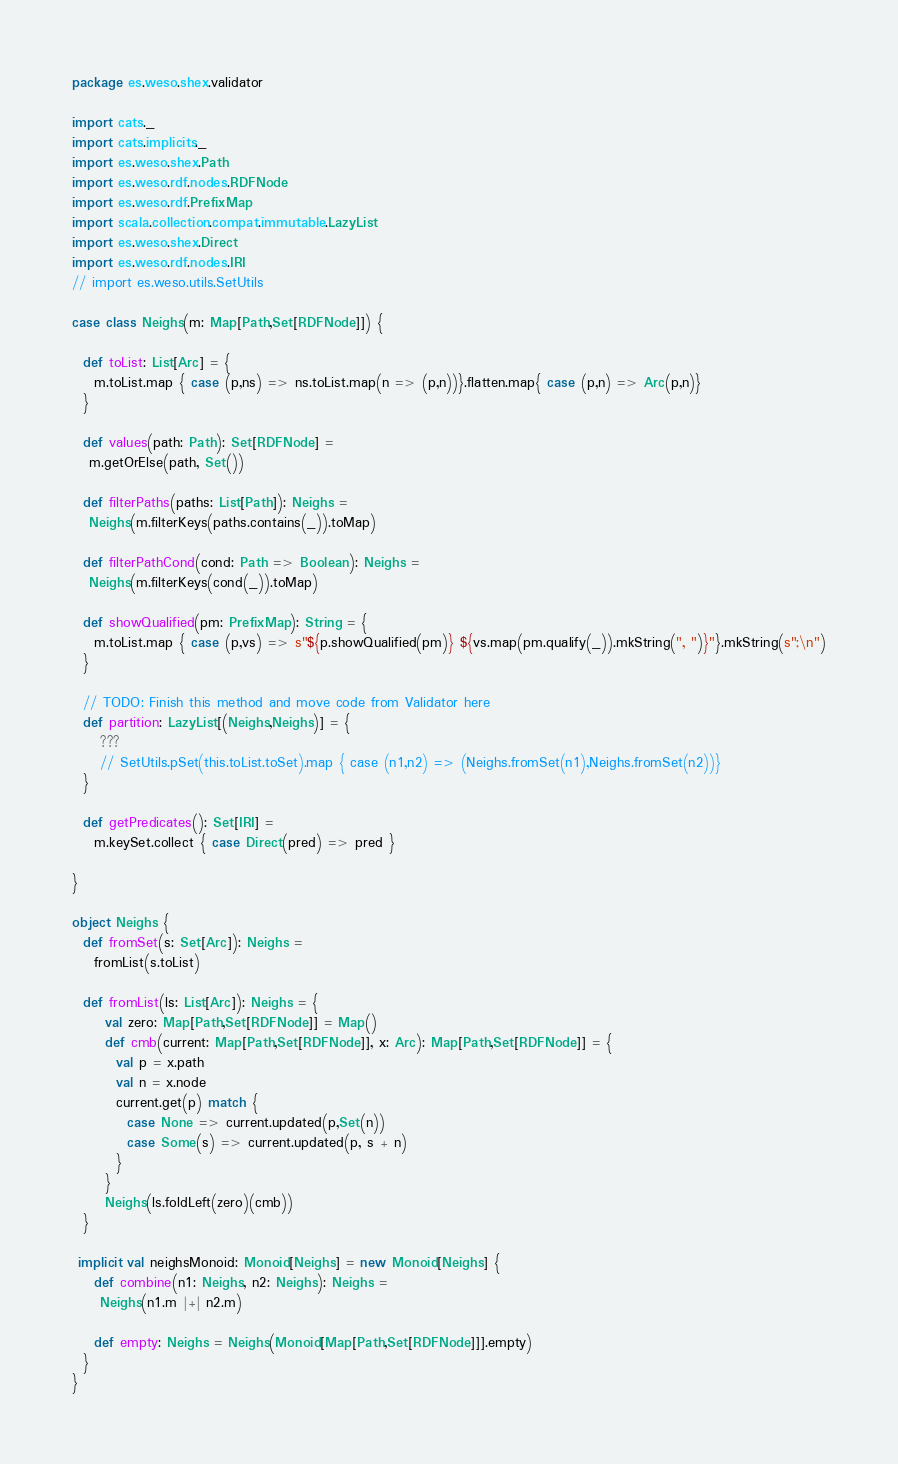<code> <loc_0><loc_0><loc_500><loc_500><_Scala_>package es.weso.shex.validator

import cats._
import cats.implicits._
import es.weso.shex.Path
import es.weso.rdf.nodes.RDFNode
import es.weso.rdf.PrefixMap
import scala.collection.compat.immutable.LazyList
import es.weso.shex.Direct
import es.weso.rdf.nodes.IRI
// import es.weso.utils.SetUtils

case class Neighs(m: Map[Path,Set[RDFNode]]) {

  def toList: List[Arc] = {
    m.toList.map { case (p,ns) => ns.toList.map(n => (p,n))}.flatten.map{ case (p,n) => Arc(p,n)} 
  }

  def values(path: Path): Set[RDFNode] = 
   m.getOrElse(path, Set())

  def filterPaths(paths: List[Path]): Neighs = 
   Neighs(m.filterKeys(paths.contains(_)).toMap)

  def filterPathCond(cond: Path => Boolean): Neighs =
   Neighs(m.filterKeys(cond(_)).toMap) 

  def showQualified(pm: PrefixMap): String = {
    m.toList.map { case (p,vs) => s"${p.showQualified(pm)} ${vs.map(pm.qualify(_)).mkString(", ")}"}.mkString(s";\n")
  } 

  // TODO: Finish this method and move code from Validator here
  def partition: LazyList[(Neighs,Neighs)] = {
     ??? 
     // SetUtils.pSet(this.toList.toSet).map { case (n1,n2) => (Neighs.fromSet(n1),Neighs.fromSet(n2))} 
  }

  def getPredicates(): Set[IRI] = 
    m.keySet.collect { case Direct(pred) => pred }

} 

object Neighs {
  def fromSet(s: Set[Arc]): Neighs = 
    fromList(s.toList)

  def fromList(ls: List[Arc]): Neighs = {
      val zero: Map[Path,Set[RDFNode]] = Map()
      def cmb(current: Map[Path,Set[RDFNode]], x: Arc): Map[Path,Set[RDFNode]] = {
        val p = x.path
        val n = x.node  
        current.get(p) match {
          case None => current.updated(p,Set(n))
          case Some(s) => current.updated(p, s + n)
        }
      }
      Neighs(ls.foldLeft(zero)(cmb))
  }

 implicit val neighsMonoid: Monoid[Neighs] = new Monoid[Neighs] {
    def combine(n1: Neighs, n2: Neighs): Neighs = 
     Neighs(n1.m |+| n2.m)

    def empty: Neighs = Neighs(Monoid[Map[Path,Set[RDFNode]]].empty)
  } 
}</code> 